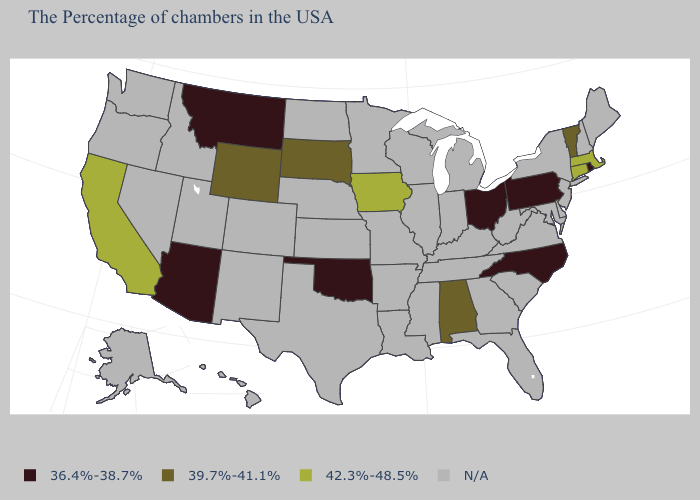Name the states that have a value in the range 39.7%-41.1%?
Give a very brief answer. Vermont, Alabama, South Dakota, Wyoming. What is the lowest value in states that border Michigan?
Quick response, please. 36.4%-38.7%. How many symbols are there in the legend?
Short answer required. 4. What is the value of Montana?
Be succinct. 36.4%-38.7%. What is the lowest value in the West?
Give a very brief answer. 36.4%-38.7%. Which states have the lowest value in the West?
Concise answer only. Montana, Arizona. What is the value of Arkansas?
Answer briefly. N/A. Which states have the lowest value in the Northeast?
Answer briefly. Rhode Island, Pennsylvania. What is the value of Illinois?
Answer briefly. N/A. Which states have the lowest value in the USA?
Write a very short answer. Rhode Island, Pennsylvania, North Carolina, Ohio, Oklahoma, Montana, Arizona. Which states hav the highest value in the MidWest?
Be succinct. Iowa. Is the legend a continuous bar?
Short answer required. No. 